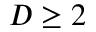<formula> <loc_0><loc_0><loc_500><loc_500>D \geq 2</formula> 